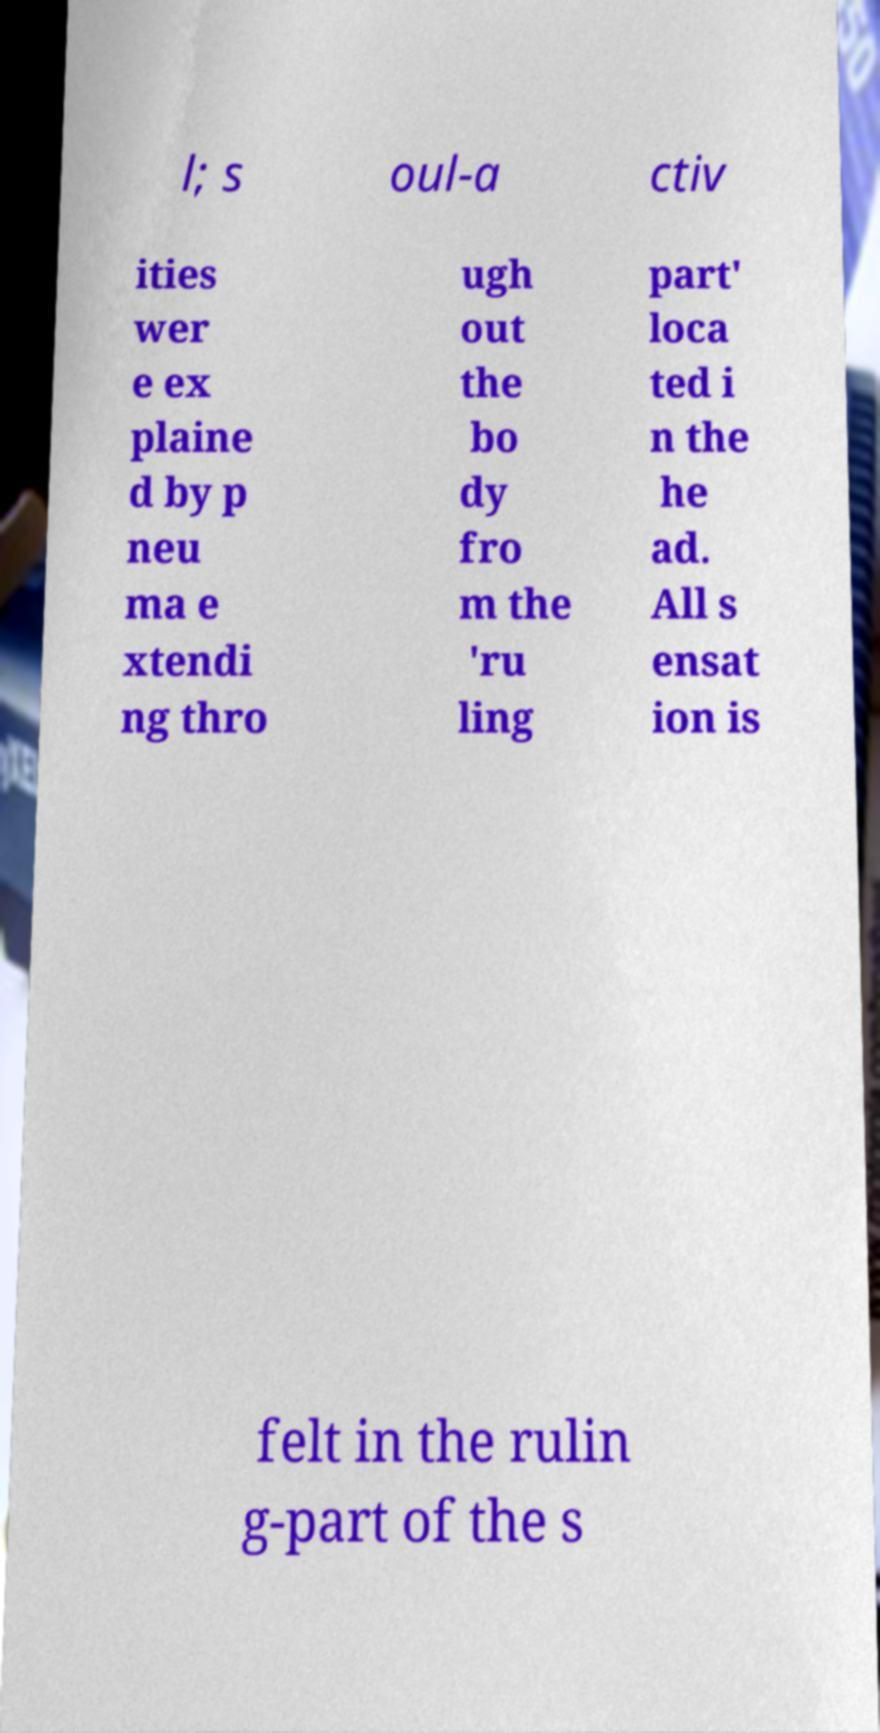There's text embedded in this image that I need extracted. Can you transcribe it verbatim? l; s oul-a ctiv ities wer e ex plaine d by p neu ma e xtendi ng thro ugh out the bo dy fro m the 'ru ling part' loca ted i n the he ad. All s ensat ion is felt in the rulin g-part of the s 